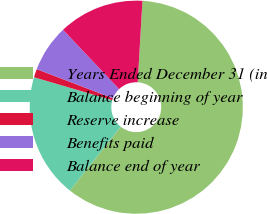<chart> <loc_0><loc_0><loc_500><loc_500><pie_chart><fcel>Years Ended December 31 (in<fcel>Balance beginning of year<fcel>Reserve increase<fcel>Benefits paid<fcel>Balance end of year<nl><fcel>59.78%<fcel>18.83%<fcel>1.28%<fcel>7.13%<fcel>12.98%<nl></chart> 